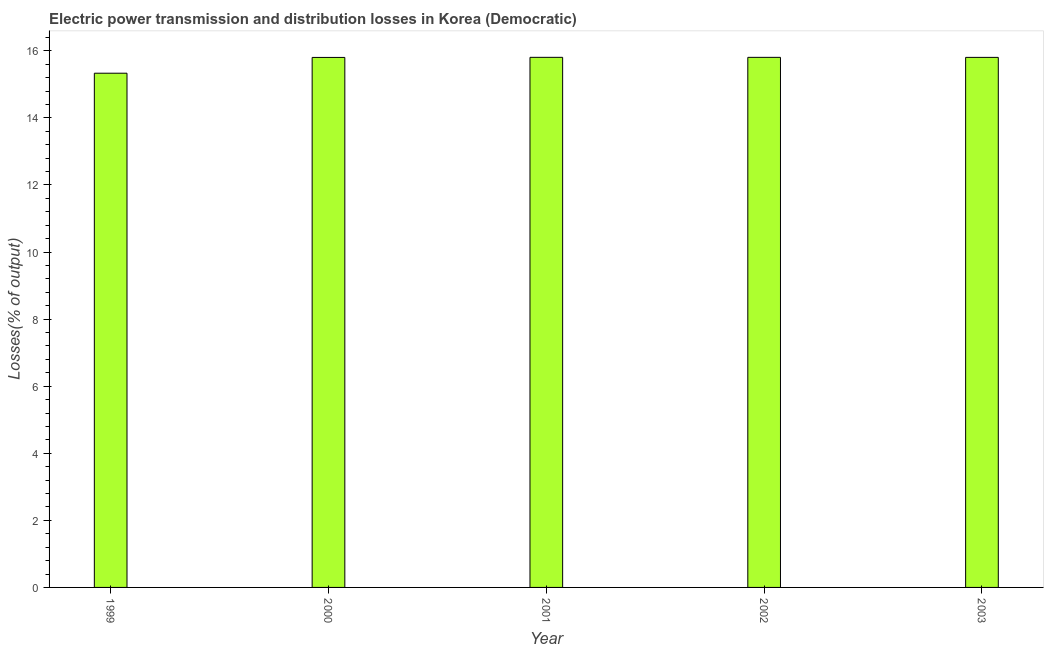Does the graph contain any zero values?
Offer a very short reply. No. What is the title of the graph?
Your answer should be very brief. Electric power transmission and distribution losses in Korea (Democratic). What is the label or title of the X-axis?
Give a very brief answer. Year. What is the label or title of the Y-axis?
Provide a short and direct response. Losses(% of output). What is the electric power transmission and distribution losses in 1999?
Your answer should be compact. 15.33. Across all years, what is the maximum electric power transmission and distribution losses?
Provide a short and direct response. 15.81. Across all years, what is the minimum electric power transmission and distribution losses?
Your answer should be very brief. 15.33. What is the sum of the electric power transmission and distribution losses?
Your answer should be compact. 78.56. What is the average electric power transmission and distribution losses per year?
Your answer should be very brief. 15.71. What is the median electric power transmission and distribution losses?
Your response must be concise. 15.81. In how many years, is the electric power transmission and distribution losses greater than 5.6 %?
Provide a short and direct response. 5. What is the ratio of the electric power transmission and distribution losses in 1999 to that in 2001?
Ensure brevity in your answer.  0.97. Is the electric power transmission and distribution losses in 1999 less than that in 2003?
Offer a very short reply. Yes. Is the difference between the electric power transmission and distribution losses in 2000 and 2003 greater than the difference between any two years?
Your answer should be very brief. No. What is the difference between the highest and the second highest electric power transmission and distribution losses?
Provide a succinct answer. 0. What is the difference between the highest and the lowest electric power transmission and distribution losses?
Provide a short and direct response. 0.47. How many bars are there?
Make the answer very short. 5. Are all the bars in the graph horizontal?
Offer a very short reply. No. How many years are there in the graph?
Provide a succinct answer. 5. What is the Losses(% of output) of 1999?
Ensure brevity in your answer.  15.33. What is the Losses(% of output) in 2000?
Provide a short and direct response. 15.8. What is the Losses(% of output) in 2001?
Ensure brevity in your answer.  15.81. What is the Losses(% of output) of 2002?
Offer a terse response. 15.81. What is the Losses(% of output) in 2003?
Ensure brevity in your answer.  15.81. What is the difference between the Losses(% of output) in 1999 and 2000?
Offer a very short reply. -0.47. What is the difference between the Losses(% of output) in 1999 and 2001?
Provide a short and direct response. -0.47. What is the difference between the Losses(% of output) in 1999 and 2002?
Give a very brief answer. -0.47. What is the difference between the Losses(% of output) in 1999 and 2003?
Your answer should be compact. -0.47. What is the difference between the Losses(% of output) in 2000 and 2001?
Make the answer very short. -0. What is the difference between the Losses(% of output) in 2000 and 2002?
Offer a very short reply. -0. What is the difference between the Losses(% of output) in 2000 and 2003?
Your answer should be very brief. -0. What is the difference between the Losses(% of output) in 2001 and 2002?
Your response must be concise. 0. What is the difference between the Losses(% of output) in 2001 and 2003?
Provide a short and direct response. 0. What is the difference between the Losses(% of output) in 2002 and 2003?
Make the answer very short. 0. What is the ratio of the Losses(% of output) in 1999 to that in 2002?
Keep it short and to the point. 0.97. What is the ratio of the Losses(% of output) in 2000 to that in 2002?
Your answer should be compact. 1. What is the ratio of the Losses(% of output) in 2001 to that in 2002?
Your answer should be compact. 1. What is the ratio of the Losses(% of output) in 2001 to that in 2003?
Offer a very short reply. 1. What is the ratio of the Losses(% of output) in 2002 to that in 2003?
Offer a very short reply. 1. 